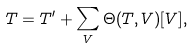<formula> <loc_0><loc_0><loc_500><loc_500>T = T ^ { \prime } + \sum _ { V } \Theta ( T , V ) [ V ] ,</formula> 